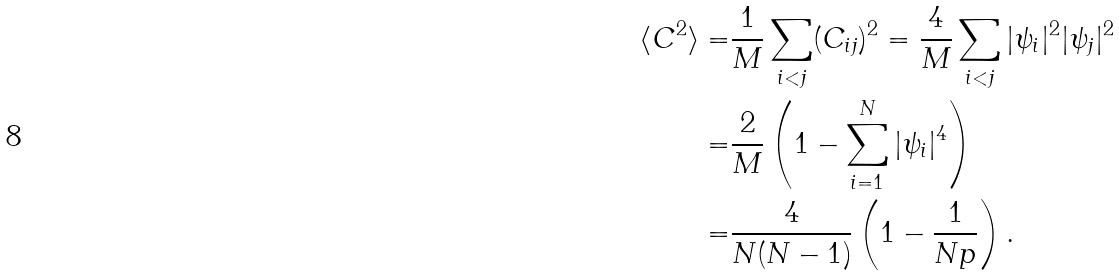<formula> <loc_0><loc_0><loc_500><loc_500>\langle C ^ { 2 } \rangle = & \frac { 1 } { M } \sum _ { i < j } ( C _ { i j } ) ^ { 2 } = \frac { 4 } { M } \sum _ { i < j } | \psi _ { i } | ^ { 2 } | \psi _ { j } | ^ { 2 } \\ = & \frac { 2 } { M } \left ( 1 - \sum _ { i = 1 } ^ { N } | \psi _ { i } | ^ { 4 } \right ) \\ = & \frac { 4 } { N ( N - 1 ) } \left ( 1 - \frac { 1 } { N p } \right ) .</formula> 